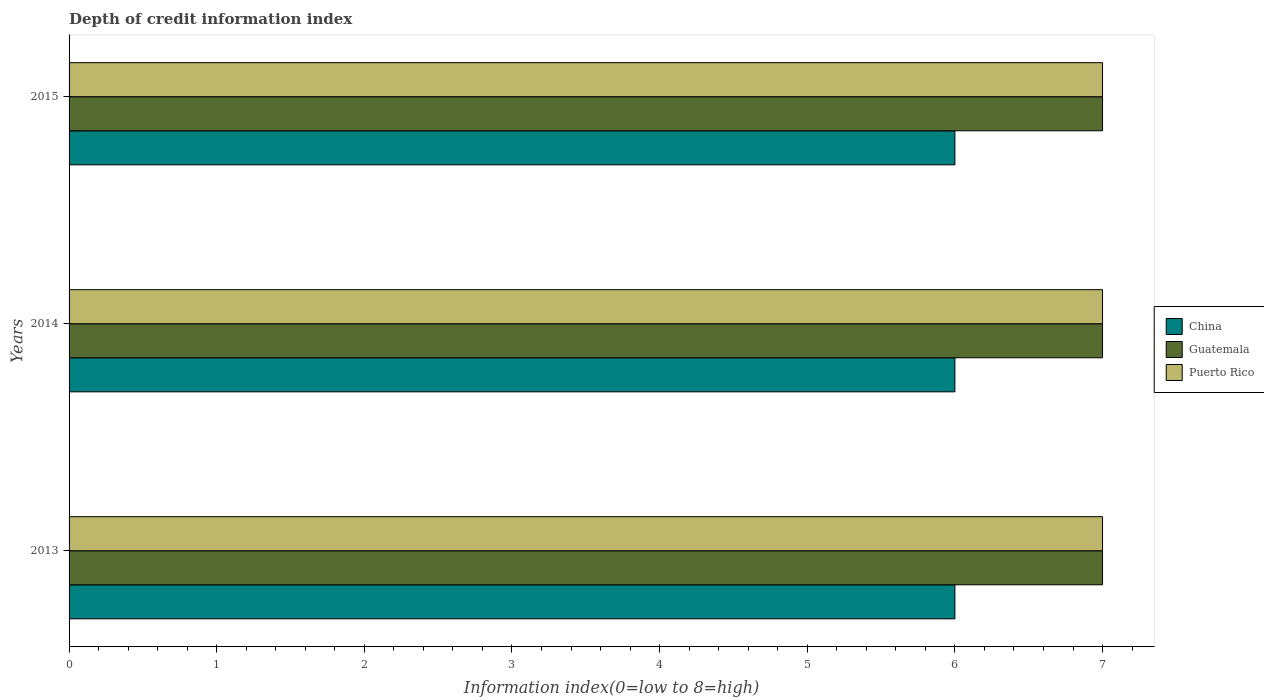How many groups of bars are there?
Offer a very short reply. 3. Are the number of bars per tick equal to the number of legend labels?
Offer a terse response. Yes. Are the number of bars on each tick of the Y-axis equal?
Your response must be concise. Yes. How many bars are there on the 1st tick from the top?
Provide a short and direct response. 3. In how many cases, is the number of bars for a given year not equal to the number of legend labels?
Your answer should be compact. 0. What is the information index in Puerto Rico in 2015?
Keep it short and to the point. 7. Across all years, what is the minimum information index in Guatemala?
Ensure brevity in your answer.  7. What is the total information index in Guatemala in the graph?
Ensure brevity in your answer.  21. What is the difference between the information index in Puerto Rico in 2014 and the information index in China in 2013?
Offer a very short reply. 1. What is the average information index in Puerto Rico per year?
Provide a short and direct response. 7. In the year 2014, what is the difference between the information index in Puerto Rico and information index in China?
Keep it short and to the point. 1. In how many years, is the information index in Puerto Rico greater than 3.4 ?
Offer a terse response. 3. What is the ratio of the information index in China in 2013 to that in 2014?
Offer a very short reply. 1. Is the information index in Puerto Rico in 2013 less than that in 2014?
Your response must be concise. No. Is the difference between the information index in Puerto Rico in 2014 and 2015 greater than the difference between the information index in China in 2014 and 2015?
Offer a very short reply. No. What is the difference between the highest and the second highest information index in China?
Keep it short and to the point. 0. In how many years, is the information index in Guatemala greater than the average information index in Guatemala taken over all years?
Your answer should be compact. 0. Is the sum of the information index in Guatemala in 2013 and 2014 greater than the maximum information index in China across all years?
Your response must be concise. Yes. What does the 2nd bar from the top in 2013 represents?
Provide a short and direct response. Guatemala. What does the 2nd bar from the bottom in 2014 represents?
Your answer should be very brief. Guatemala. Is it the case that in every year, the sum of the information index in China and information index in Puerto Rico is greater than the information index in Guatemala?
Provide a succinct answer. Yes. Are the values on the major ticks of X-axis written in scientific E-notation?
Your response must be concise. No. Does the graph contain any zero values?
Your answer should be very brief. No. Where does the legend appear in the graph?
Your answer should be compact. Center right. How are the legend labels stacked?
Your answer should be compact. Vertical. What is the title of the graph?
Your response must be concise. Depth of credit information index. Does "Philippines" appear as one of the legend labels in the graph?
Offer a terse response. No. What is the label or title of the X-axis?
Offer a very short reply. Information index(0=low to 8=high). What is the Information index(0=low to 8=high) in China in 2013?
Provide a short and direct response. 6. What is the Information index(0=low to 8=high) of Guatemala in 2013?
Offer a terse response. 7. What is the Information index(0=low to 8=high) in Puerto Rico in 2013?
Give a very brief answer. 7. What is the Information index(0=low to 8=high) of China in 2014?
Give a very brief answer. 6. What is the Information index(0=low to 8=high) of China in 2015?
Make the answer very short. 6. What is the Information index(0=low to 8=high) of Guatemala in 2015?
Provide a short and direct response. 7. Across all years, what is the minimum Information index(0=low to 8=high) in China?
Make the answer very short. 6. Across all years, what is the minimum Information index(0=low to 8=high) of Guatemala?
Give a very brief answer. 7. What is the total Information index(0=low to 8=high) in China in the graph?
Your answer should be very brief. 18. What is the total Information index(0=low to 8=high) in Guatemala in the graph?
Give a very brief answer. 21. What is the difference between the Information index(0=low to 8=high) in China in 2013 and that in 2014?
Ensure brevity in your answer.  0. What is the difference between the Information index(0=low to 8=high) in Guatemala in 2013 and that in 2014?
Give a very brief answer. 0. What is the difference between the Information index(0=low to 8=high) in China in 2013 and that in 2015?
Keep it short and to the point. 0. What is the difference between the Information index(0=low to 8=high) in Puerto Rico in 2013 and that in 2015?
Your answer should be compact. 0. What is the difference between the Information index(0=low to 8=high) in Guatemala in 2014 and that in 2015?
Keep it short and to the point. 0. What is the difference between the Information index(0=low to 8=high) in China in 2013 and the Information index(0=low to 8=high) in Guatemala in 2014?
Your answer should be compact. -1. What is the difference between the Information index(0=low to 8=high) in Guatemala in 2013 and the Information index(0=low to 8=high) in Puerto Rico in 2014?
Your response must be concise. 0. What is the difference between the Information index(0=low to 8=high) of China in 2013 and the Information index(0=low to 8=high) of Guatemala in 2015?
Give a very brief answer. -1. What is the difference between the Information index(0=low to 8=high) of Guatemala in 2013 and the Information index(0=low to 8=high) of Puerto Rico in 2015?
Your answer should be very brief. 0. What is the difference between the Information index(0=low to 8=high) in China in 2014 and the Information index(0=low to 8=high) in Guatemala in 2015?
Your answer should be very brief. -1. What is the difference between the Information index(0=low to 8=high) in Guatemala in 2014 and the Information index(0=low to 8=high) in Puerto Rico in 2015?
Ensure brevity in your answer.  0. In the year 2013, what is the difference between the Information index(0=low to 8=high) of China and Information index(0=low to 8=high) of Guatemala?
Your answer should be very brief. -1. In the year 2013, what is the difference between the Information index(0=low to 8=high) in China and Information index(0=low to 8=high) in Puerto Rico?
Provide a succinct answer. -1. In the year 2013, what is the difference between the Information index(0=low to 8=high) of Guatemala and Information index(0=low to 8=high) of Puerto Rico?
Your answer should be compact. 0. In the year 2014, what is the difference between the Information index(0=low to 8=high) of China and Information index(0=low to 8=high) of Guatemala?
Provide a succinct answer. -1. In the year 2014, what is the difference between the Information index(0=low to 8=high) in Guatemala and Information index(0=low to 8=high) in Puerto Rico?
Keep it short and to the point. 0. In the year 2015, what is the difference between the Information index(0=low to 8=high) of Guatemala and Information index(0=low to 8=high) of Puerto Rico?
Give a very brief answer. 0. What is the ratio of the Information index(0=low to 8=high) of Guatemala in 2013 to that in 2014?
Provide a short and direct response. 1. What is the ratio of the Information index(0=low to 8=high) in Guatemala in 2013 to that in 2015?
Make the answer very short. 1. What is the ratio of the Information index(0=low to 8=high) in China in 2014 to that in 2015?
Offer a terse response. 1. What is the ratio of the Information index(0=low to 8=high) of Guatemala in 2014 to that in 2015?
Offer a terse response. 1. What is the difference between the highest and the second highest Information index(0=low to 8=high) in Guatemala?
Ensure brevity in your answer.  0. What is the difference between the highest and the second highest Information index(0=low to 8=high) of Puerto Rico?
Ensure brevity in your answer.  0. What is the difference between the highest and the lowest Information index(0=low to 8=high) in China?
Make the answer very short. 0. 